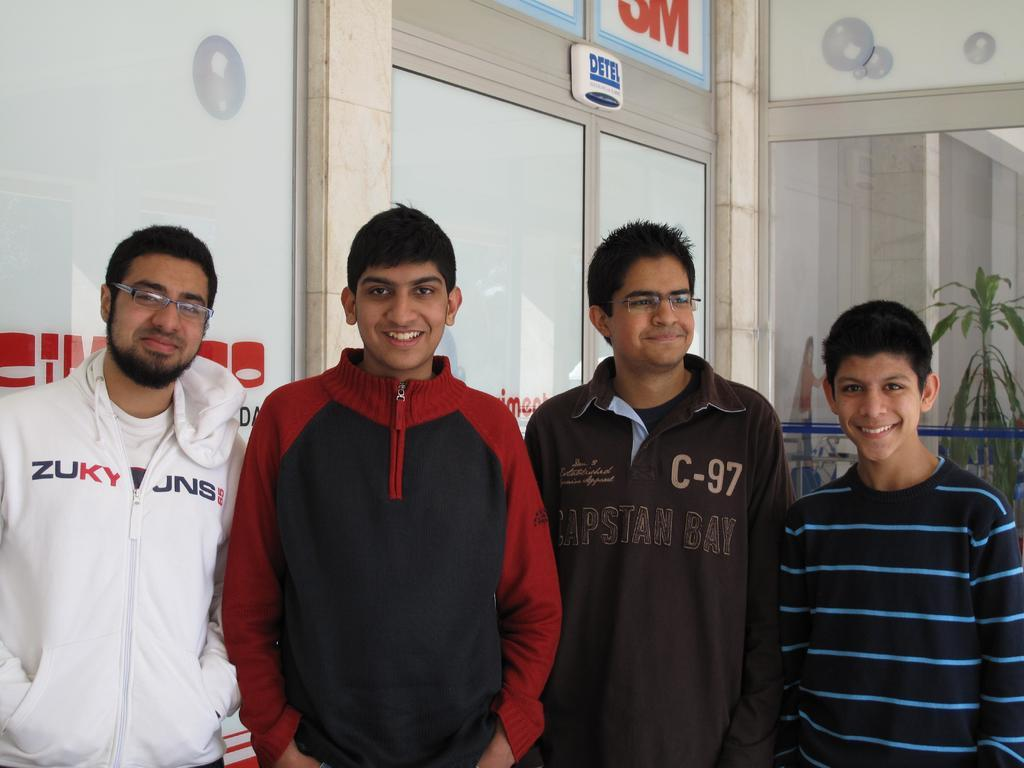<image>
Provide a brief description of the given image. One older man and three boys of whom two are wearing printed tops which say ZUKY JNS and C-97 Capstan Bay from left to right. 